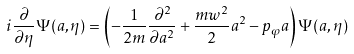<formula> <loc_0><loc_0><loc_500><loc_500>i \frac { \partial } { \partial \eta } \Psi ( a , \eta ) = \left ( - \frac { 1 } { 2 m } \frac { \partial ^ { 2 } } { \partial a ^ { 2 } } + \frac { m w ^ { 2 } } { 2 } a ^ { 2 } - p _ { \varphi } a \right ) \Psi ( a , \eta )</formula> 